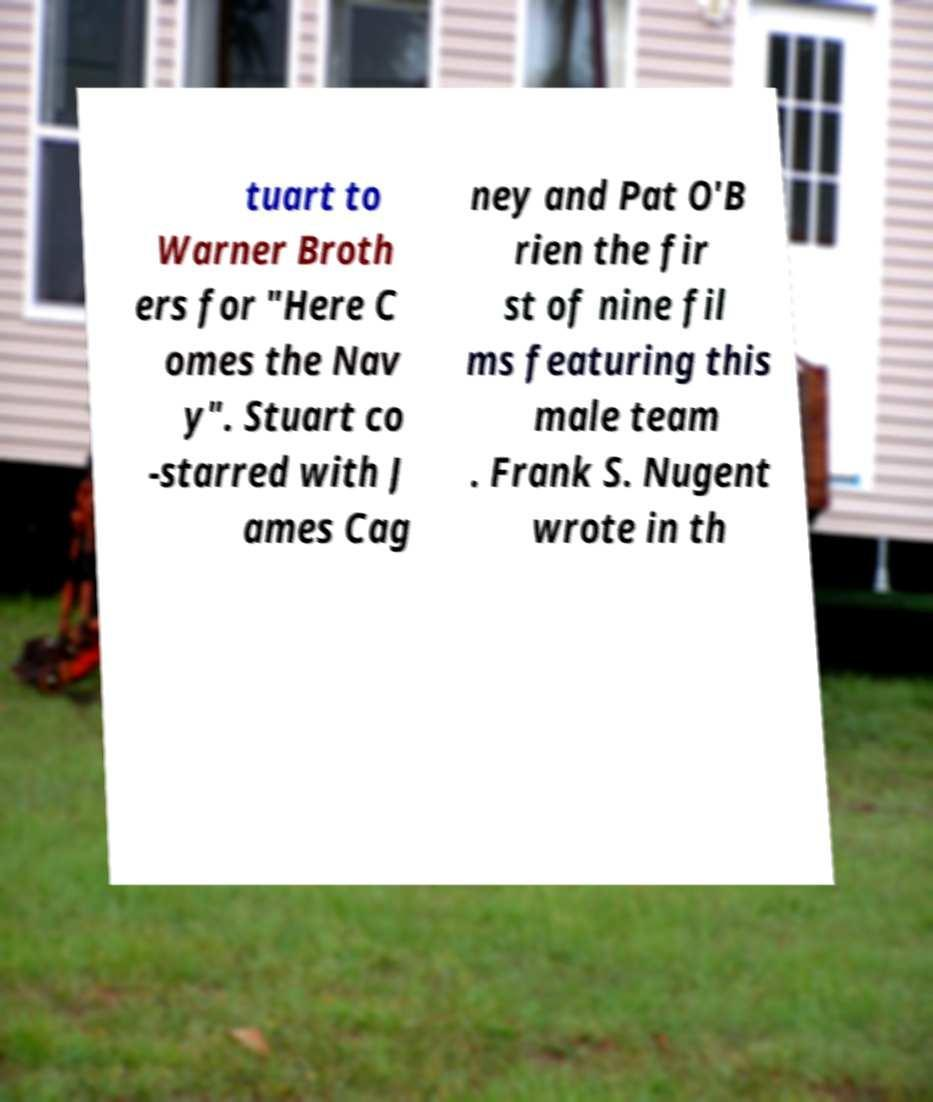Please read and relay the text visible in this image. What does it say? tuart to Warner Broth ers for "Here C omes the Nav y". Stuart co -starred with J ames Cag ney and Pat O'B rien the fir st of nine fil ms featuring this male team . Frank S. Nugent wrote in th 